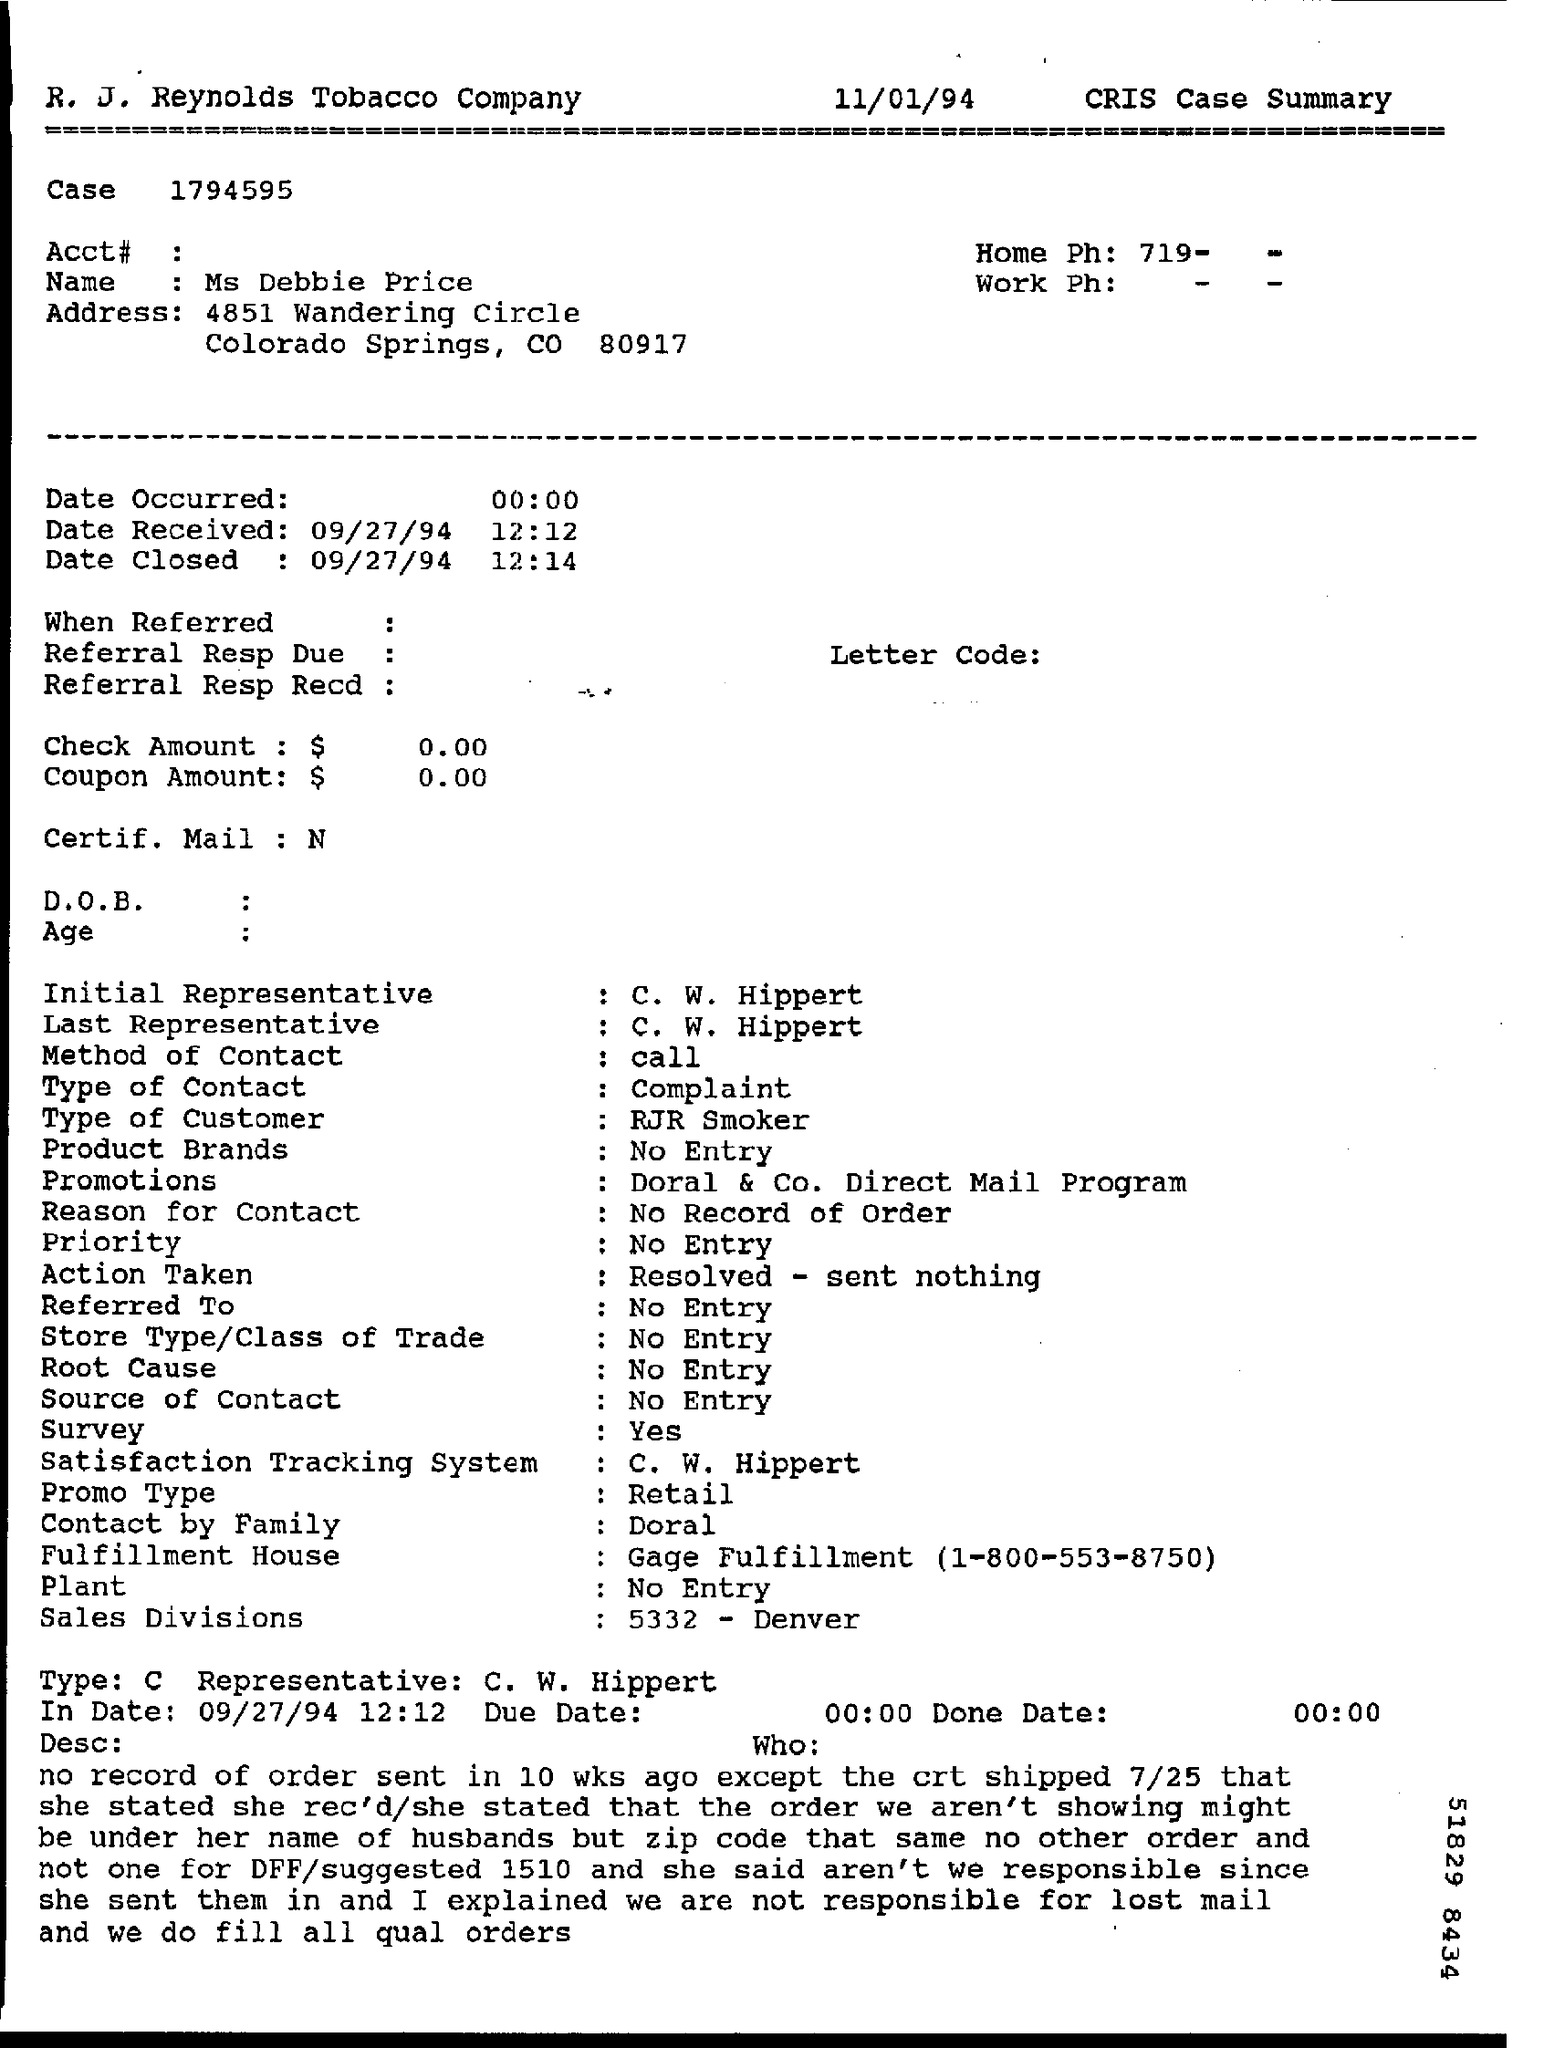What is the name mentioned ?
Provide a short and direct response. MS Debbie Price. What is the in date mentioned ?
Offer a very short reply. 09/27/94. What is the time mentioned in the in date ?
Provide a succinct answer. 12:12. 